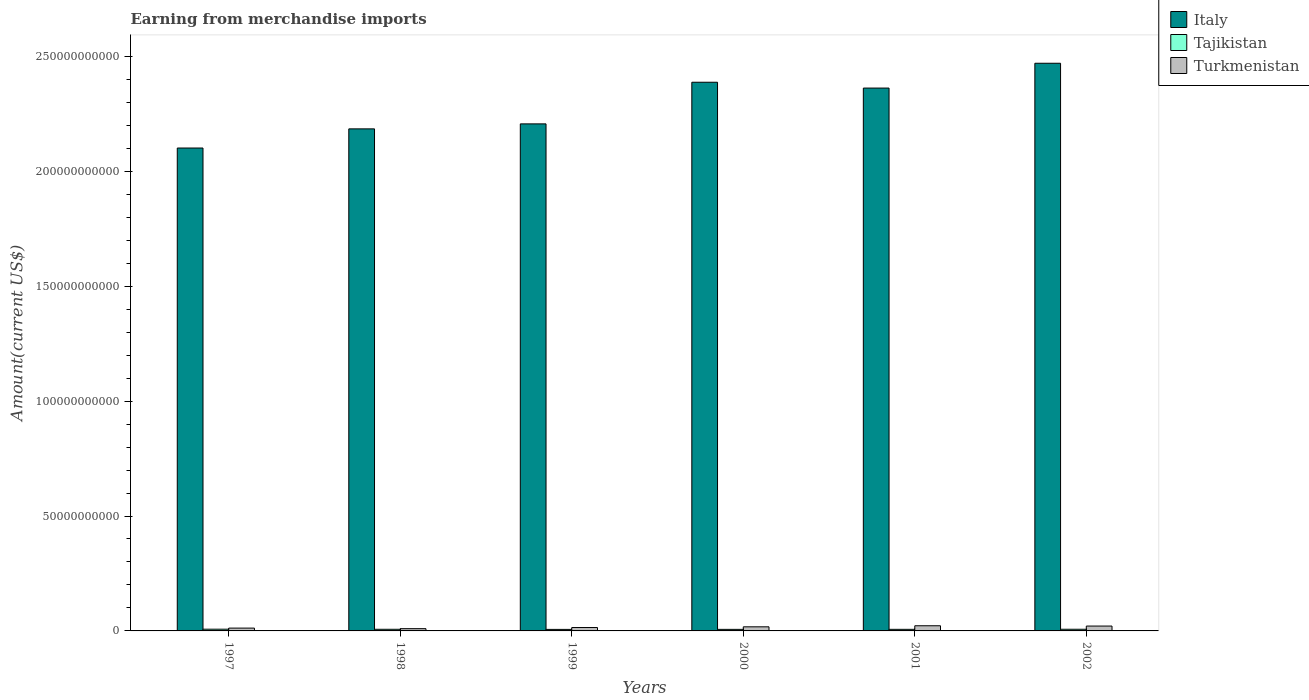How many different coloured bars are there?
Your answer should be very brief. 3. Are the number of bars per tick equal to the number of legend labels?
Offer a very short reply. Yes. In how many cases, is the number of bars for a given year not equal to the number of legend labels?
Ensure brevity in your answer.  0. What is the amount earned from merchandise imports in Turkmenistan in 2001?
Keep it short and to the point. 2.25e+09. Across all years, what is the maximum amount earned from merchandise imports in Italy?
Make the answer very short. 2.47e+11. Across all years, what is the minimum amount earned from merchandise imports in Turkmenistan?
Make the answer very short. 9.80e+08. What is the total amount earned from merchandise imports in Tajikistan in the graph?
Make the answer very short. 4.21e+09. What is the difference between the amount earned from merchandise imports in Tajikistan in 1999 and that in 2000?
Offer a terse response. -1.20e+07. What is the difference between the amount earned from merchandise imports in Italy in 2000 and the amount earned from merchandise imports in Tajikistan in 1999?
Keep it short and to the point. 2.38e+11. What is the average amount earned from merchandise imports in Italy per year?
Offer a terse response. 2.29e+11. In the year 2001, what is the difference between the amount earned from merchandise imports in Turkmenistan and amount earned from merchandise imports in Italy?
Provide a short and direct response. -2.34e+11. In how many years, is the amount earned from merchandise imports in Turkmenistan greater than 90000000000 US$?
Your response must be concise. 0. What is the ratio of the amount earned from merchandise imports in Tajikistan in 1998 to that in 2000?
Your response must be concise. 1.05. Is the difference between the amount earned from merchandise imports in Turkmenistan in 2001 and 2002 greater than the difference between the amount earned from merchandise imports in Italy in 2001 and 2002?
Ensure brevity in your answer.  Yes. What is the difference between the highest and the second highest amount earned from merchandise imports in Tajikistan?
Provide a short and direct response. 2.90e+07. What is the difference between the highest and the lowest amount earned from merchandise imports in Tajikistan?
Provide a succinct answer. 8.70e+07. What does the 3rd bar from the left in 1999 represents?
Make the answer very short. Turkmenistan. What does the 2nd bar from the right in 1998 represents?
Keep it short and to the point. Tajikistan. How many years are there in the graph?
Your answer should be very brief. 6. What is the difference between two consecutive major ticks on the Y-axis?
Offer a very short reply. 5.00e+1. Does the graph contain grids?
Ensure brevity in your answer.  No. How many legend labels are there?
Keep it short and to the point. 3. How are the legend labels stacked?
Make the answer very short. Vertical. What is the title of the graph?
Keep it short and to the point. Earning from merchandise imports. What is the label or title of the X-axis?
Your answer should be compact. Years. What is the label or title of the Y-axis?
Make the answer very short. Amount(current US$). What is the Amount(current US$) in Italy in 1997?
Your answer should be compact. 2.10e+11. What is the Amount(current US$) of Tajikistan in 1997?
Your response must be concise. 7.50e+08. What is the Amount(current US$) in Turkmenistan in 1997?
Offer a terse response. 1.23e+09. What is the Amount(current US$) in Italy in 1998?
Your answer should be compact. 2.18e+11. What is the Amount(current US$) in Tajikistan in 1998?
Offer a terse response. 7.10e+08. What is the Amount(current US$) in Turkmenistan in 1998?
Make the answer very short. 9.80e+08. What is the Amount(current US$) in Italy in 1999?
Give a very brief answer. 2.21e+11. What is the Amount(current US$) in Tajikistan in 1999?
Offer a terse response. 6.63e+08. What is the Amount(current US$) in Turkmenistan in 1999?
Your answer should be compact. 1.48e+09. What is the Amount(current US$) of Italy in 2000?
Offer a terse response. 2.39e+11. What is the Amount(current US$) in Tajikistan in 2000?
Offer a terse response. 6.75e+08. What is the Amount(current US$) in Turkmenistan in 2000?
Give a very brief answer. 1.79e+09. What is the Amount(current US$) in Italy in 2001?
Offer a terse response. 2.36e+11. What is the Amount(current US$) of Tajikistan in 2001?
Offer a terse response. 6.88e+08. What is the Amount(current US$) of Turkmenistan in 2001?
Your answer should be compact. 2.25e+09. What is the Amount(current US$) of Italy in 2002?
Your answer should be compact. 2.47e+11. What is the Amount(current US$) of Tajikistan in 2002?
Your answer should be compact. 7.21e+08. What is the Amount(current US$) of Turkmenistan in 2002?
Give a very brief answer. 2.12e+09. Across all years, what is the maximum Amount(current US$) in Italy?
Keep it short and to the point. 2.47e+11. Across all years, what is the maximum Amount(current US$) in Tajikistan?
Your answer should be compact. 7.50e+08. Across all years, what is the maximum Amount(current US$) of Turkmenistan?
Make the answer very short. 2.25e+09. Across all years, what is the minimum Amount(current US$) in Italy?
Make the answer very short. 2.10e+11. Across all years, what is the minimum Amount(current US$) of Tajikistan?
Provide a short and direct response. 6.63e+08. Across all years, what is the minimum Amount(current US$) of Turkmenistan?
Provide a succinct answer. 9.80e+08. What is the total Amount(current US$) in Italy in the graph?
Ensure brevity in your answer.  1.37e+12. What is the total Amount(current US$) of Tajikistan in the graph?
Give a very brief answer. 4.21e+09. What is the total Amount(current US$) of Turkmenistan in the graph?
Your response must be concise. 9.84e+09. What is the difference between the Amount(current US$) in Italy in 1997 and that in 1998?
Provide a short and direct response. -8.33e+09. What is the difference between the Amount(current US$) in Tajikistan in 1997 and that in 1998?
Your response must be concise. 4.00e+07. What is the difference between the Amount(current US$) in Turkmenistan in 1997 and that in 1998?
Keep it short and to the point. 2.50e+08. What is the difference between the Amount(current US$) in Italy in 1997 and that in 1999?
Ensure brevity in your answer.  -1.05e+1. What is the difference between the Amount(current US$) of Tajikistan in 1997 and that in 1999?
Your answer should be compact. 8.70e+07. What is the difference between the Amount(current US$) of Turkmenistan in 1997 and that in 1999?
Ensure brevity in your answer.  -2.48e+08. What is the difference between the Amount(current US$) in Italy in 1997 and that in 2000?
Your response must be concise. -2.86e+1. What is the difference between the Amount(current US$) of Tajikistan in 1997 and that in 2000?
Your response must be concise. 7.50e+07. What is the difference between the Amount(current US$) in Turkmenistan in 1997 and that in 2000?
Offer a very short reply. -5.56e+08. What is the difference between the Amount(current US$) of Italy in 1997 and that in 2001?
Make the answer very short. -2.61e+1. What is the difference between the Amount(current US$) of Tajikistan in 1997 and that in 2001?
Your response must be concise. 6.20e+07. What is the difference between the Amount(current US$) in Turkmenistan in 1997 and that in 2001?
Provide a succinct answer. -1.02e+09. What is the difference between the Amount(current US$) of Italy in 1997 and that in 2002?
Your response must be concise. -3.69e+1. What is the difference between the Amount(current US$) in Tajikistan in 1997 and that in 2002?
Ensure brevity in your answer.  2.90e+07. What is the difference between the Amount(current US$) in Turkmenistan in 1997 and that in 2002?
Make the answer very short. -8.90e+08. What is the difference between the Amount(current US$) in Italy in 1998 and that in 1999?
Provide a succinct answer. -2.17e+09. What is the difference between the Amount(current US$) of Tajikistan in 1998 and that in 1999?
Keep it short and to the point. 4.70e+07. What is the difference between the Amount(current US$) of Turkmenistan in 1998 and that in 1999?
Make the answer very short. -4.98e+08. What is the difference between the Amount(current US$) in Italy in 1998 and that in 2000?
Ensure brevity in your answer.  -2.03e+1. What is the difference between the Amount(current US$) in Tajikistan in 1998 and that in 2000?
Make the answer very short. 3.50e+07. What is the difference between the Amount(current US$) in Turkmenistan in 1998 and that in 2000?
Offer a very short reply. -8.06e+08. What is the difference between the Amount(current US$) of Italy in 1998 and that in 2001?
Keep it short and to the point. -1.78e+1. What is the difference between the Amount(current US$) of Tajikistan in 1998 and that in 2001?
Keep it short and to the point. 2.20e+07. What is the difference between the Amount(current US$) of Turkmenistan in 1998 and that in 2001?
Provide a short and direct response. -1.27e+09. What is the difference between the Amount(current US$) of Italy in 1998 and that in 2002?
Give a very brief answer. -2.86e+1. What is the difference between the Amount(current US$) of Tajikistan in 1998 and that in 2002?
Make the answer very short. -1.10e+07. What is the difference between the Amount(current US$) of Turkmenistan in 1998 and that in 2002?
Keep it short and to the point. -1.14e+09. What is the difference between the Amount(current US$) in Italy in 1999 and that in 2000?
Your response must be concise. -1.81e+1. What is the difference between the Amount(current US$) of Tajikistan in 1999 and that in 2000?
Provide a short and direct response. -1.20e+07. What is the difference between the Amount(current US$) in Turkmenistan in 1999 and that in 2000?
Your answer should be compact. -3.08e+08. What is the difference between the Amount(current US$) in Italy in 1999 and that in 2001?
Your answer should be very brief. -1.56e+1. What is the difference between the Amount(current US$) in Tajikistan in 1999 and that in 2001?
Offer a very short reply. -2.50e+07. What is the difference between the Amount(current US$) of Turkmenistan in 1999 and that in 2001?
Your answer should be compact. -7.72e+08. What is the difference between the Amount(current US$) in Italy in 1999 and that in 2002?
Provide a short and direct response. -2.64e+1. What is the difference between the Amount(current US$) of Tajikistan in 1999 and that in 2002?
Your answer should be compact. -5.80e+07. What is the difference between the Amount(current US$) in Turkmenistan in 1999 and that in 2002?
Your response must be concise. -6.42e+08. What is the difference between the Amount(current US$) in Italy in 2000 and that in 2001?
Your response must be concise. 2.54e+09. What is the difference between the Amount(current US$) of Tajikistan in 2000 and that in 2001?
Keep it short and to the point. -1.30e+07. What is the difference between the Amount(current US$) of Turkmenistan in 2000 and that in 2001?
Ensure brevity in your answer.  -4.64e+08. What is the difference between the Amount(current US$) of Italy in 2000 and that in 2002?
Provide a short and direct response. -8.26e+09. What is the difference between the Amount(current US$) of Tajikistan in 2000 and that in 2002?
Offer a terse response. -4.60e+07. What is the difference between the Amount(current US$) of Turkmenistan in 2000 and that in 2002?
Provide a short and direct response. -3.34e+08. What is the difference between the Amount(current US$) of Italy in 2001 and that in 2002?
Ensure brevity in your answer.  -1.08e+1. What is the difference between the Amount(current US$) of Tajikistan in 2001 and that in 2002?
Your answer should be very brief. -3.30e+07. What is the difference between the Amount(current US$) of Turkmenistan in 2001 and that in 2002?
Provide a short and direct response. 1.30e+08. What is the difference between the Amount(current US$) in Italy in 1997 and the Amount(current US$) in Tajikistan in 1998?
Give a very brief answer. 2.09e+11. What is the difference between the Amount(current US$) of Italy in 1997 and the Amount(current US$) of Turkmenistan in 1998?
Offer a very short reply. 2.09e+11. What is the difference between the Amount(current US$) of Tajikistan in 1997 and the Amount(current US$) of Turkmenistan in 1998?
Provide a short and direct response. -2.30e+08. What is the difference between the Amount(current US$) of Italy in 1997 and the Amount(current US$) of Tajikistan in 1999?
Provide a succinct answer. 2.09e+11. What is the difference between the Amount(current US$) of Italy in 1997 and the Amount(current US$) of Turkmenistan in 1999?
Offer a terse response. 2.09e+11. What is the difference between the Amount(current US$) in Tajikistan in 1997 and the Amount(current US$) in Turkmenistan in 1999?
Your response must be concise. -7.28e+08. What is the difference between the Amount(current US$) in Italy in 1997 and the Amount(current US$) in Tajikistan in 2000?
Offer a very short reply. 2.09e+11. What is the difference between the Amount(current US$) of Italy in 1997 and the Amount(current US$) of Turkmenistan in 2000?
Your answer should be compact. 2.08e+11. What is the difference between the Amount(current US$) of Tajikistan in 1997 and the Amount(current US$) of Turkmenistan in 2000?
Keep it short and to the point. -1.04e+09. What is the difference between the Amount(current US$) of Italy in 1997 and the Amount(current US$) of Tajikistan in 2001?
Offer a very short reply. 2.09e+11. What is the difference between the Amount(current US$) in Italy in 1997 and the Amount(current US$) in Turkmenistan in 2001?
Your answer should be very brief. 2.08e+11. What is the difference between the Amount(current US$) in Tajikistan in 1997 and the Amount(current US$) in Turkmenistan in 2001?
Provide a short and direct response. -1.50e+09. What is the difference between the Amount(current US$) of Italy in 1997 and the Amount(current US$) of Tajikistan in 2002?
Give a very brief answer. 2.09e+11. What is the difference between the Amount(current US$) of Italy in 1997 and the Amount(current US$) of Turkmenistan in 2002?
Provide a succinct answer. 2.08e+11. What is the difference between the Amount(current US$) in Tajikistan in 1997 and the Amount(current US$) in Turkmenistan in 2002?
Your response must be concise. -1.37e+09. What is the difference between the Amount(current US$) in Italy in 1998 and the Amount(current US$) in Tajikistan in 1999?
Provide a short and direct response. 2.18e+11. What is the difference between the Amount(current US$) of Italy in 1998 and the Amount(current US$) of Turkmenistan in 1999?
Your response must be concise. 2.17e+11. What is the difference between the Amount(current US$) of Tajikistan in 1998 and the Amount(current US$) of Turkmenistan in 1999?
Keep it short and to the point. -7.68e+08. What is the difference between the Amount(current US$) in Italy in 1998 and the Amount(current US$) in Tajikistan in 2000?
Your answer should be compact. 2.18e+11. What is the difference between the Amount(current US$) in Italy in 1998 and the Amount(current US$) in Turkmenistan in 2000?
Give a very brief answer. 2.17e+11. What is the difference between the Amount(current US$) of Tajikistan in 1998 and the Amount(current US$) of Turkmenistan in 2000?
Give a very brief answer. -1.08e+09. What is the difference between the Amount(current US$) in Italy in 1998 and the Amount(current US$) in Tajikistan in 2001?
Offer a terse response. 2.18e+11. What is the difference between the Amount(current US$) in Italy in 1998 and the Amount(current US$) in Turkmenistan in 2001?
Ensure brevity in your answer.  2.16e+11. What is the difference between the Amount(current US$) in Tajikistan in 1998 and the Amount(current US$) in Turkmenistan in 2001?
Your answer should be compact. -1.54e+09. What is the difference between the Amount(current US$) in Italy in 1998 and the Amount(current US$) in Tajikistan in 2002?
Your answer should be compact. 2.18e+11. What is the difference between the Amount(current US$) in Italy in 1998 and the Amount(current US$) in Turkmenistan in 2002?
Your answer should be very brief. 2.16e+11. What is the difference between the Amount(current US$) in Tajikistan in 1998 and the Amount(current US$) in Turkmenistan in 2002?
Provide a succinct answer. -1.41e+09. What is the difference between the Amount(current US$) in Italy in 1999 and the Amount(current US$) in Tajikistan in 2000?
Make the answer very short. 2.20e+11. What is the difference between the Amount(current US$) in Italy in 1999 and the Amount(current US$) in Turkmenistan in 2000?
Provide a short and direct response. 2.19e+11. What is the difference between the Amount(current US$) of Tajikistan in 1999 and the Amount(current US$) of Turkmenistan in 2000?
Make the answer very short. -1.12e+09. What is the difference between the Amount(current US$) in Italy in 1999 and the Amount(current US$) in Tajikistan in 2001?
Offer a very short reply. 2.20e+11. What is the difference between the Amount(current US$) of Italy in 1999 and the Amount(current US$) of Turkmenistan in 2001?
Keep it short and to the point. 2.18e+11. What is the difference between the Amount(current US$) in Tajikistan in 1999 and the Amount(current US$) in Turkmenistan in 2001?
Give a very brief answer. -1.59e+09. What is the difference between the Amount(current US$) of Italy in 1999 and the Amount(current US$) of Tajikistan in 2002?
Ensure brevity in your answer.  2.20e+11. What is the difference between the Amount(current US$) of Italy in 1999 and the Amount(current US$) of Turkmenistan in 2002?
Your response must be concise. 2.19e+11. What is the difference between the Amount(current US$) in Tajikistan in 1999 and the Amount(current US$) in Turkmenistan in 2002?
Give a very brief answer. -1.46e+09. What is the difference between the Amount(current US$) in Italy in 2000 and the Amount(current US$) in Tajikistan in 2001?
Provide a short and direct response. 2.38e+11. What is the difference between the Amount(current US$) of Italy in 2000 and the Amount(current US$) of Turkmenistan in 2001?
Ensure brevity in your answer.  2.37e+11. What is the difference between the Amount(current US$) of Tajikistan in 2000 and the Amount(current US$) of Turkmenistan in 2001?
Offer a terse response. -1.58e+09. What is the difference between the Amount(current US$) of Italy in 2000 and the Amount(current US$) of Tajikistan in 2002?
Provide a short and direct response. 2.38e+11. What is the difference between the Amount(current US$) of Italy in 2000 and the Amount(current US$) of Turkmenistan in 2002?
Offer a terse response. 2.37e+11. What is the difference between the Amount(current US$) in Tajikistan in 2000 and the Amount(current US$) in Turkmenistan in 2002?
Your answer should be very brief. -1.44e+09. What is the difference between the Amount(current US$) of Italy in 2001 and the Amount(current US$) of Tajikistan in 2002?
Keep it short and to the point. 2.35e+11. What is the difference between the Amount(current US$) in Italy in 2001 and the Amount(current US$) in Turkmenistan in 2002?
Give a very brief answer. 2.34e+11. What is the difference between the Amount(current US$) of Tajikistan in 2001 and the Amount(current US$) of Turkmenistan in 2002?
Ensure brevity in your answer.  -1.43e+09. What is the average Amount(current US$) in Italy per year?
Give a very brief answer. 2.29e+11. What is the average Amount(current US$) of Tajikistan per year?
Your answer should be very brief. 7.01e+08. What is the average Amount(current US$) in Turkmenistan per year?
Provide a short and direct response. 1.64e+09. In the year 1997, what is the difference between the Amount(current US$) of Italy and Amount(current US$) of Tajikistan?
Provide a short and direct response. 2.09e+11. In the year 1997, what is the difference between the Amount(current US$) in Italy and Amount(current US$) in Turkmenistan?
Make the answer very short. 2.09e+11. In the year 1997, what is the difference between the Amount(current US$) in Tajikistan and Amount(current US$) in Turkmenistan?
Provide a short and direct response. -4.80e+08. In the year 1998, what is the difference between the Amount(current US$) in Italy and Amount(current US$) in Tajikistan?
Your response must be concise. 2.18e+11. In the year 1998, what is the difference between the Amount(current US$) of Italy and Amount(current US$) of Turkmenistan?
Provide a short and direct response. 2.17e+11. In the year 1998, what is the difference between the Amount(current US$) in Tajikistan and Amount(current US$) in Turkmenistan?
Your answer should be very brief. -2.70e+08. In the year 1999, what is the difference between the Amount(current US$) of Italy and Amount(current US$) of Tajikistan?
Provide a short and direct response. 2.20e+11. In the year 1999, what is the difference between the Amount(current US$) in Italy and Amount(current US$) in Turkmenistan?
Give a very brief answer. 2.19e+11. In the year 1999, what is the difference between the Amount(current US$) in Tajikistan and Amount(current US$) in Turkmenistan?
Make the answer very short. -8.15e+08. In the year 2000, what is the difference between the Amount(current US$) in Italy and Amount(current US$) in Tajikistan?
Give a very brief answer. 2.38e+11. In the year 2000, what is the difference between the Amount(current US$) in Italy and Amount(current US$) in Turkmenistan?
Your answer should be compact. 2.37e+11. In the year 2000, what is the difference between the Amount(current US$) in Tajikistan and Amount(current US$) in Turkmenistan?
Ensure brevity in your answer.  -1.11e+09. In the year 2001, what is the difference between the Amount(current US$) in Italy and Amount(current US$) in Tajikistan?
Keep it short and to the point. 2.36e+11. In the year 2001, what is the difference between the Amount(current US$) in Italy and Amount(current US$) in Turkmenistan?
Ensure brevity in your answer.  2.34e+11. In the year 2001, what is the difference between the Amount(current US$) of Tajikistan and Amount(current US$) of Turkmenistan?
Your response must be concise. -1.56e+09. In the year 2002, what is the difference between the Amount(current US$) in Italy and Amount(current US$) in Tajikistan?
Make the answer very short. 2.46e+11. In the year 2002, what is the difference between the Amount(current US$) of Italy and Amount(current US$) of Turkmenistan?
Your answer should be very brief. 2.45e+11. In the year 2002, what is the difference between the Amount(current US$) of Tajikistan and Amount(current US$) of Turkmenistan?
Offer a very short reply. -1.40e+09. What is the ratio of the Amount(current US$) of Italy in 1997 to that in 1998?
Your response must be concise. 0.96. What is the ratio of the Amount(current US$) in Tajikistan in 1997 to that in 1998?
Provide a short and direct response. 1.06. What is the ratio of the Amount(current US$) in Turkmenistan in 1997 to that in 1998?
Your response must be concise. 1.26. What is the ratio of the Amount(current US$) of Tajikistan in 1997 to that in 1999?
Provide a succinct answer. 1.13. What is the ratio of the Amount(current US$) of Turkmenistan in 1997 to that in 1999?
Offer a terse response. 0.83. What is the ratio of the Amount(current US$) of Italy in 1997 to that in 2000?
Provide a succinct answer. 0.88. What is the ratio of the Amount(current US$) in Tajikistan in 1997 to that in 2000?
Offer a very short reply. 1.11. What is the ratio of the Amount(current US$) of Turkmenistan in 1997 to that in 2000?
Keep it short and to the point. 0.69. What is the ratio of the Amount(current US$) of Italy in 1997 to that in 2001?
Give a very brief answer. 0.89. What is the ratio of the Amount(current US$) of Tajikistan in 1997 to that in 2001?
Make the answer very short. 1.09. What is the ratio of the Amount(current US$) of Turkmenistan in 1997 to that in 2001?
Offer a very short reply. 0.55. What is the ratio of the Amount(current US$) of Italy in 1997 to that in 2002?
Give a very brief answer. 0.85. What is the ratio of the Amount(current US$) of Tajikistan in 1997 to that in 2002?
Your answer should be very brief. 1.04. What is the ratio of the Amount(current US$) of Turkmenistan in 1997 to that in 2002?
Your answer should be compact. 0.58. What is the ratio of the Amount(current US$) in Italy in 1998 to that in 1999?
Provide a succinct answer. 0.99. What is the ratio of the Amount(current US$) in Tajikistan in 1998 to that in 1999?
Your answer should be very brief. 1.07. What is the ratio of the Amount(current US$) of Turkmenistan in 1998 to that in 1999?
Ensure brevity in your answer.  0.66. What is the ratio of the Amount(current US$) of Italy in 1998 to that in 2000?
Offer a terse response. 0.92. What is the ratio of the Amount(current US$) in Tajikistan in 1998 to that in 2000?
Your response must be concise. 1.05. What is the ratio of the Amount(current US$) in Turkmenistan in 1998 to that in 2000?
Ensure brevity in your answer.  0.55. What is the ratio of the Amount(current US$) of Italy in 1998 to that in 2001?
Make the answer very short. 0.92. What is the ratio of the Amount(current US$) of Tajikistan in 1998 to that in 2001?
Give a very brief answer. 1.03. What is the ratio of the Amount(current US$) of Turkmenistan in 1998 to that in 2001?
Make the answer very short. 0.44. What is the ratio of the Amount(current US$) of Italy in 1998 to that in 2002?
Offer a very short reply. 0.88. What is the ratio of the Amount(current US$) in Tajikistan in 1998 to that in 2002?
Make the answer very short. 0.98. What is the ratio of the Amount(current US$) of Turkmenistan in 1998 to that in 2002?
Offer a very short reply. 0.46. What is the ratio of the Amount(current US$) of Italy in 1999 to that in 2000?
Make the answer very short. 0.92. What is the ratio of the Amount(current US$) of Tajikistan in 1999 to that in 2000?
Your answer should be compact. 0.98. What is the ratio of the Amount(current US$) of Turkmenistan in 1999 to that in 2000?
Offer a very short reply. 0.83. What is the ratio of the Amount(current US$) of Italy in 1999 to that in 2001?
Keep it short and to the point. 0.93. What is the ratio of the Amount(current US$) in Tajikistan in 1999 to that in 2001?
Your response must be concise. 0.96. What is the ratio of the Amount(current US$) in Turkmenistan in 1999 to that in 2001?
Provide a succinct answer. 0.66. What is the ratio of the Amount(current US$) of Italy in 1999 to that in 2002?
Give a very brief answer. 0.89. What is the ratio of the Amount(current US$) in Tajikistan in 1999 to that in 2002?
Provide a short and direct response. 0.92. What is the ratio of the Amount(current US$) in Turkmenistan in 1999 to that in 2002?
Make the answer very short. 0.7. What is the ratio of the Amount(current US$) of Italy in 2000 to that in 2001?
Provide a succinct answer. 1.01. What is the ratio of the Amount(current US$) of Tajikistan in 2000 to that in 2001?
Ensure brevity in your answer.  0.98. What is the ratio of the Amount(current US$) of Turkmenistan in 2000 to that in 2001?
Your response must be concise. 0.79. What is the ratio of the Amount(current US$) in Italy in 2000 to that in 2002?
Your answer should be compact. 0.97. What is the ratio of the Amount(current US$) of Tajikistan in 2000 to that in 2002?
Make the answer very short. 0.94. What is the ratio of the Amount(current US$) of Turkmenistan in 2000 to that in 2002?
Keep it short and to the point. 0.84. What is the ratio of the Amount(current US$) of Italy in 2001 to that in 2002?
Your answer should be compact. 0.96. What is the ratio of the Amount(current US$) of Tajikistan in 2001 to that in 2002?
Your response must be concise. 0.95. What is the ratio of the Amount(current US$) in Turkmenistan in 2001 to that in 2002?
Offer a very short reply. 1.06. What is the difference between the highest and the second highest Amount(current US$) of Italy?
Your response must be concise. 8.26e+09. What is the difference between the highest and the second highest Amount(current US$) in Tajikistan?
Offer a terse response. 2.90e+07. What is the difference between the highest and the second highest Amount(current US$) of Turkmenistan?
Give a very brief answer. 1.30e+08. What is the difference between the highest and the lowest Amount(current US$) of Italy?
Your response must be concise. 3.69e+1. What is the difference between the highest and the lowest Amount(current US$) of Tajikistan?
Make the answer very short. 8.70e+07. What is the difference between the highest and the lowest Amount(current US$) of Turkmenistan?
Provide a succinct answer. 1.27e+09. 